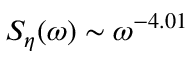Convert formula to latex. <formula><loc_0><loc_0><loc_500><loc_500>S _ { \eta } ( \omega ) \sim \omega ^ { - 4 . 0 1 }</formula> 